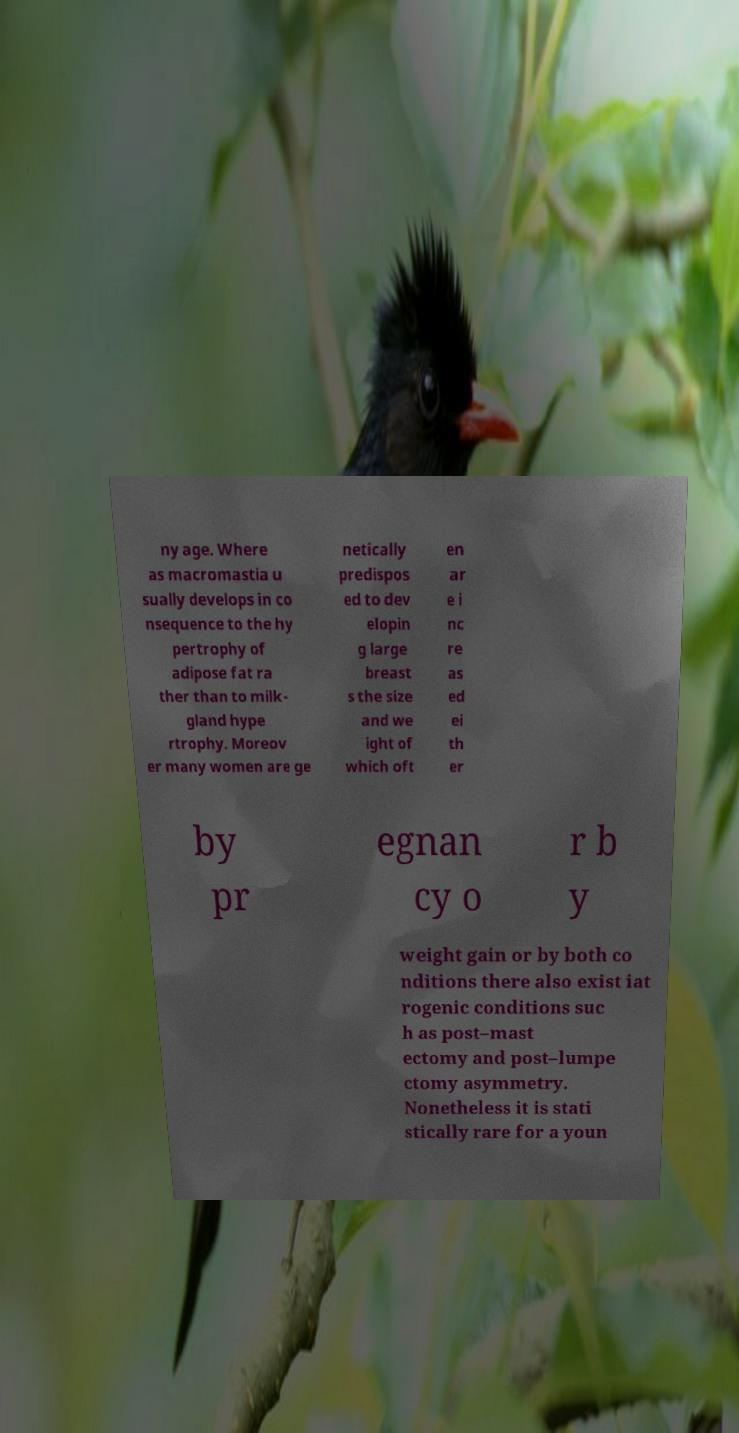What messages or text are displayed in this image? I need them in a readable, typed format. ny age. Where as macromastia u sually develops in co nsequence to the hy pertrophy of adipose fat ra ther than to milk- gland hype rtrophy. Moreov er many women are ge netically predispos ed to dev elopin g large breast s the size and we ight of which oft en ar e i nc re as ed ei th er by pr egnan cy o r b y weight gain or by both co nditions there also exist iat rogenic conditions suc h as post–mast ectomy and post–lumpe ctomy asymmetry. Nonetheless it is stati stically rare for a youn 